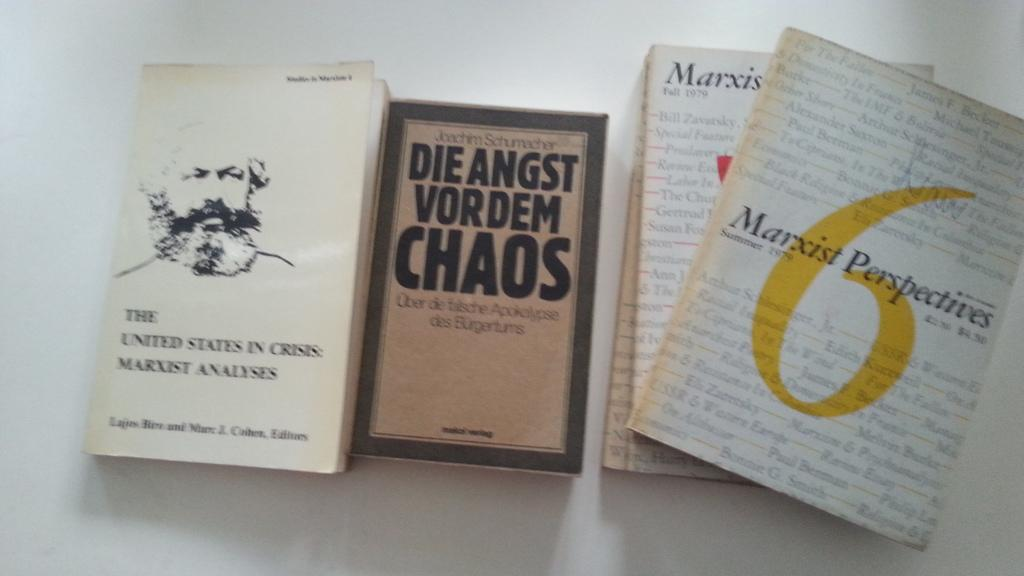<image>
Share a concise interpretation of the image provided. A copy of Die Angst Vordem Chaos sits with some other books. 